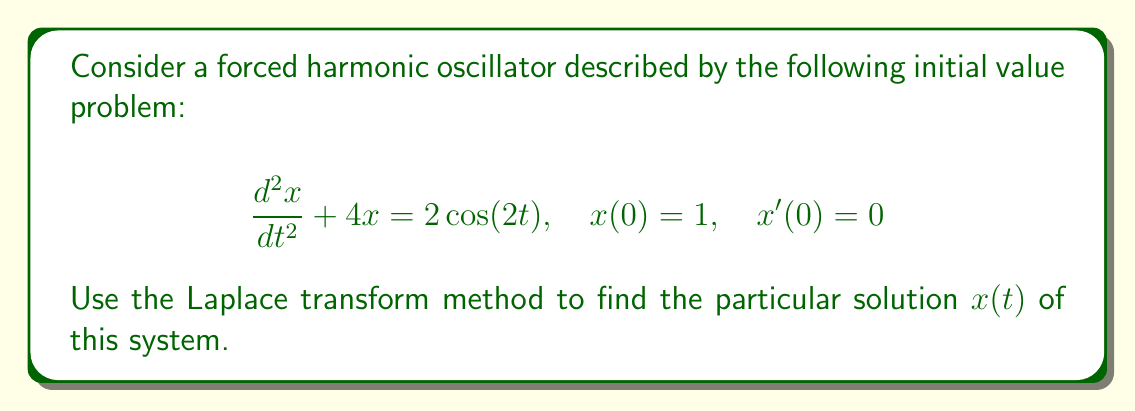Can you answer this question? Let's solve this problem step by step using the Laplace transform method:

1) First, we take the Laplace transform of both sides of the differential equation:

   $\mathcal{L}\{\frac{d^2x}{dt^2} + 4x\} = \mathcal{L}\{2\cos(2t)\}$

2) Using the properties of the Laplace transform:

   $s^2X(s) - sx(0) - x'(0) + 4X(s) = \frac{2s}{s^2 + 4}$

3) Substituting the initial conditions $x(0) = 1$ and $x'(0) = 0$:

   $s^2X(s) - s + 4X(s) = \frac{2s}{s^2 + 4}$

4) Factoring out $X(s)$:

   $X(s)(s^2 + 4) = s + \frac{2s}{s^2 + 4}$

5) Solving for $X(s)$:

   $X(s) = \frac{s}{s^2 + 4} + \frac{2s}{(s^2 + 4)^2}$

6) We can decompose this into partial fractions:

   $X(s) = \frac{s}{s^2 + 4} + \frac{1}{s^2 + 4} - \frac{1}{(s^2 + 4)}$

7) Now we can take the inverse Laplace transform:

   $x(t) = \mathcal{L}^{-1}\{\frac{s}{s^2 + 4}\} + \mathcal{L}^{-1}\{\frac{1}{s^2 + 4}\} - \mathcal{L}^{-1}\{\frac{1}{(s^2 + 4)}\}$

8) Using standard Laplace transform pairs:

   $x(t) = \cos(2t) + \frac{1}{2}\sin(2t) - \frac{1}{2}t\sin(2t)$

This is the particular solution to the given initial value problem.
Answer: $x(t) = \cos(2t) + \frac{1}{2}\sin(2t) - \frac{1}{2}t\sin(2t)$ 